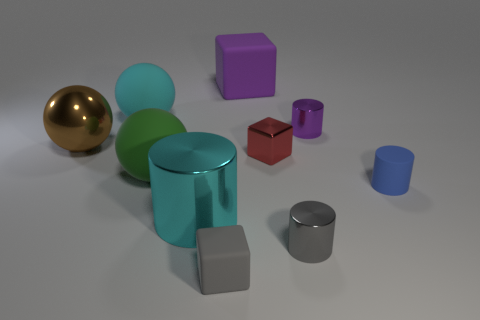Subtract all red cylinders. Subtract all blue blocks. How many cylinders are left? 4 Subtract all balls. How many objects are left? 7 Add 9 big yellow objects. How many big yellow objects exist? 9 Subtract 0 brown cubes. How many objects are left? 10 Subtract all large cubes. Subtract all big brown shiny things. How many objects are left? 8 Add 3 large cyan metal cylinders. How many large cyan metal cylinders are left? 4 